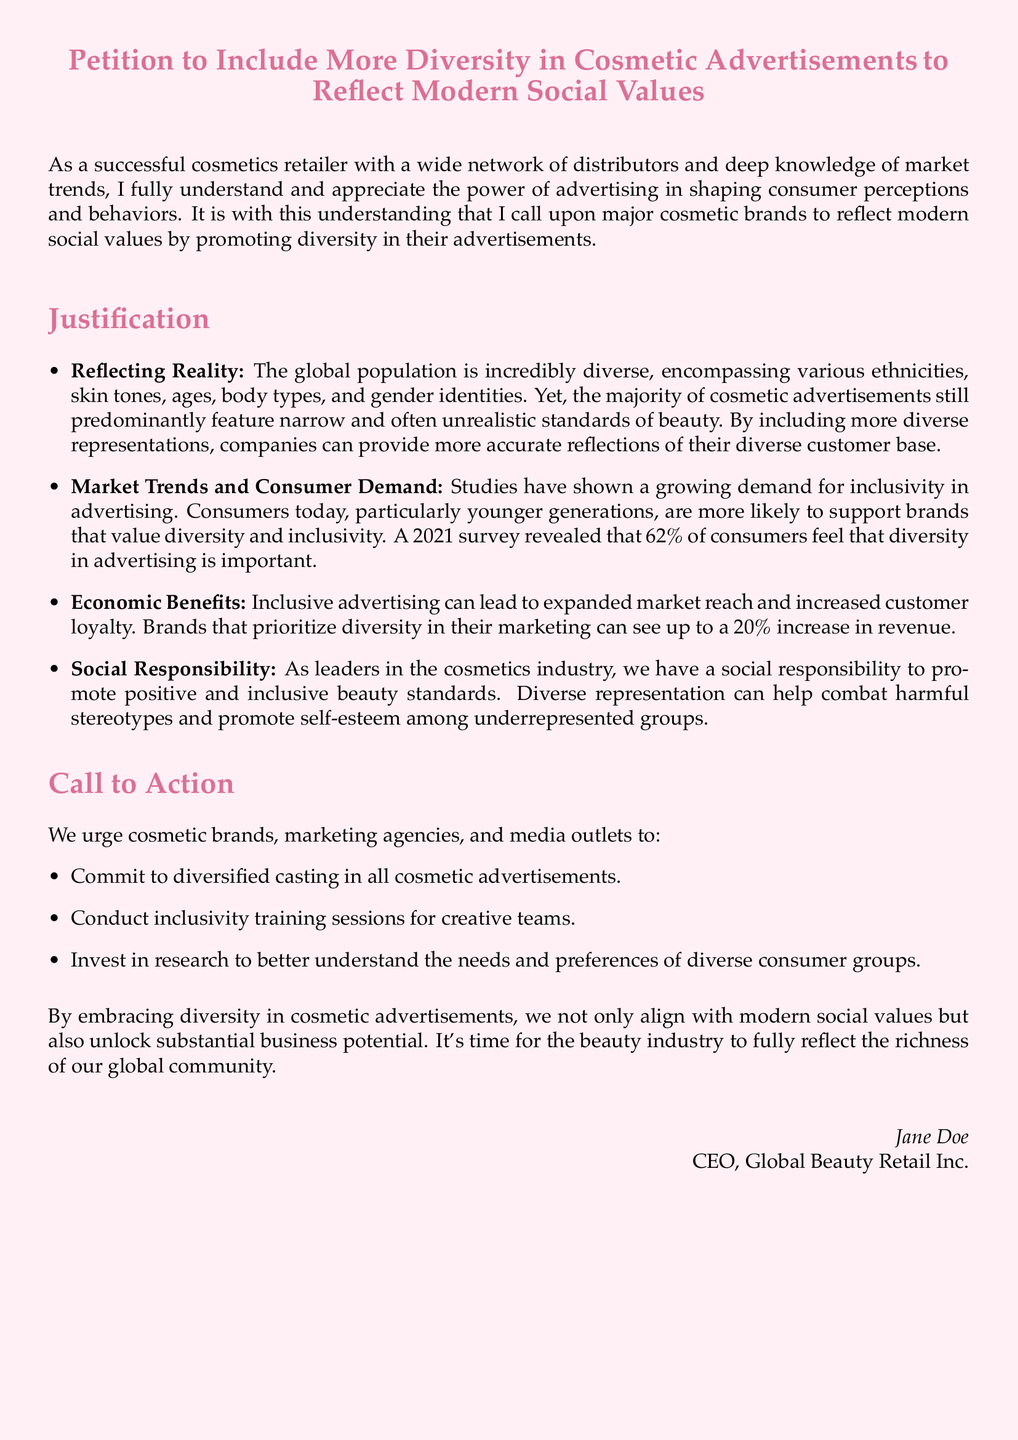What is the title of the petition? The title of the petition is clearly stated at the beginning of the document.
Answer: Petition to Include More Diversity in Cosmetic Advertisements to Reflect Modern Social Values What percentage of consumers feel that diversity in advertising is important? The document provides specific statistics regarding consumer opinions on diversity in advertising.
Answer: 62% What is one benefit of inclusive advertising mentioned in the petition? The document lists economic benefits associated with inclusive advertising.
Answer: Increased customer loyalty Who authored the petition? The author of the petition is mentioned at the end of the document.
Answer: Jane Doe What type of training do the petitioners urge creative teams to conduct? The document specifies a type of training to address inclusivity.
Answer: Inclusivity training sessions What is the main responsibility of the cosmetics industry as mentioned in the petition? The justification mentions a key responsibility of the cosmetics industry towards society.
Answer: Social responsibility How much increase in revenue can brands see by prioritizing diversity? The document provides a statistic regarding potential revenue increase related to diversity.
Answer: Up to a 20% increase How many items are listed in the call to action? The document includes a specific number of items outlining the call to action.
Answer: Three 